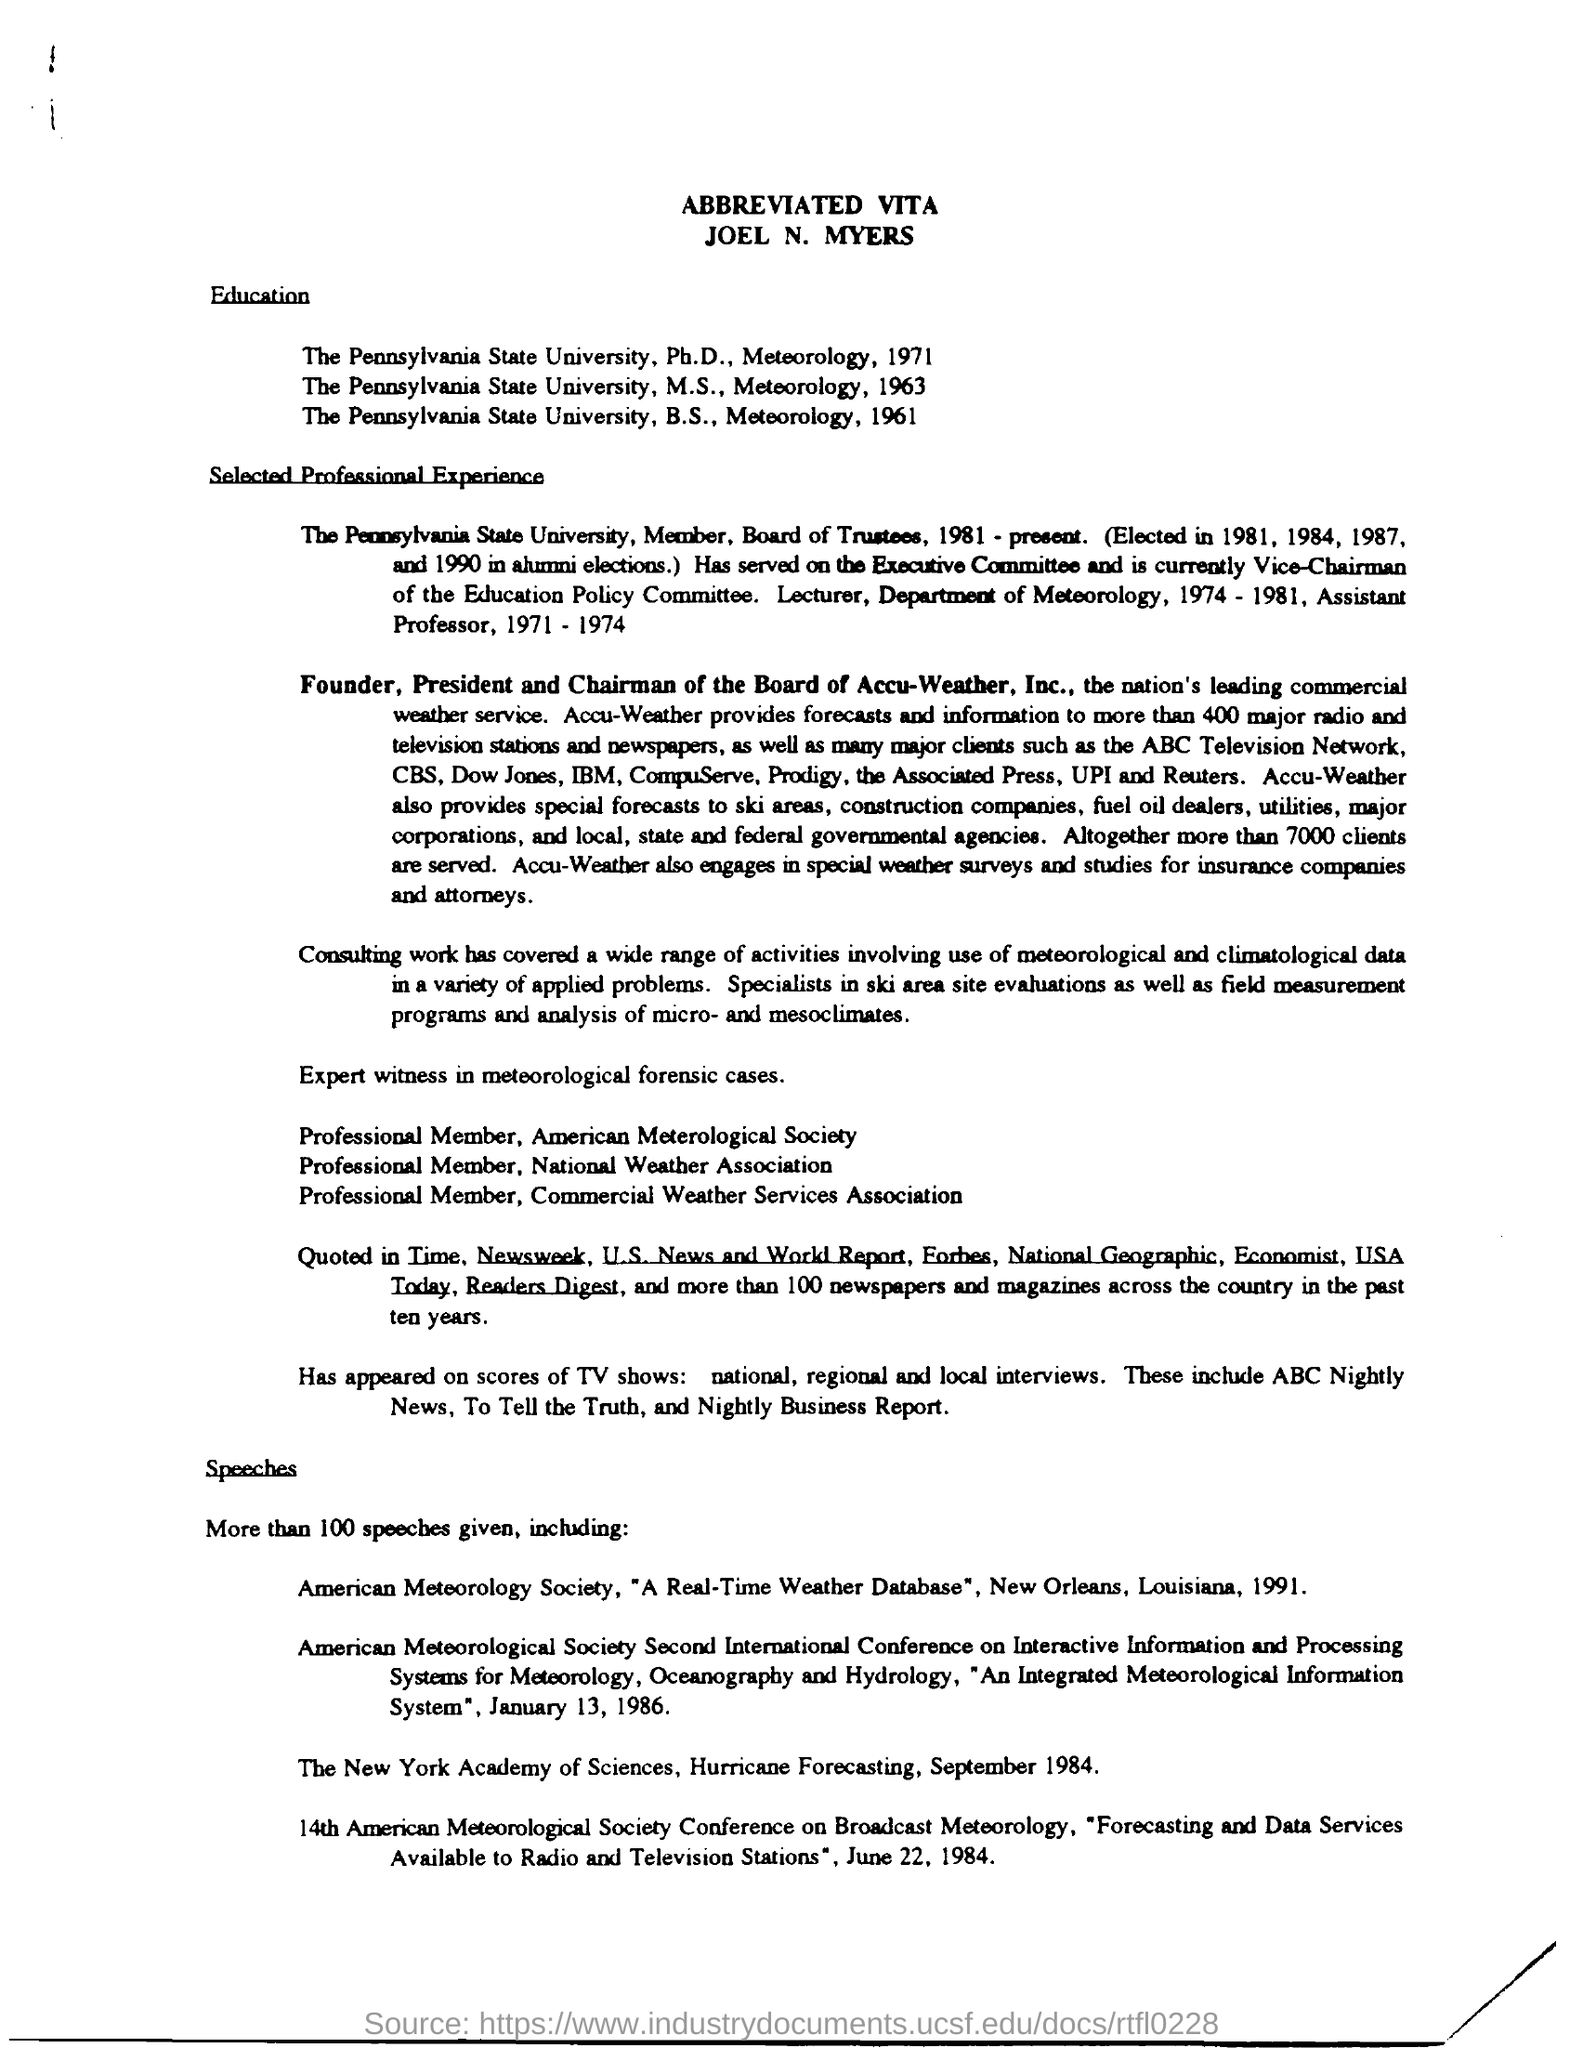Outline some significant characteristics in this image. Joel N. Myers is the founder, president, and chairman of the Board of Accu-Weather, Inc. Please provide the title of the document, as it appears in the abbreviated vita. 